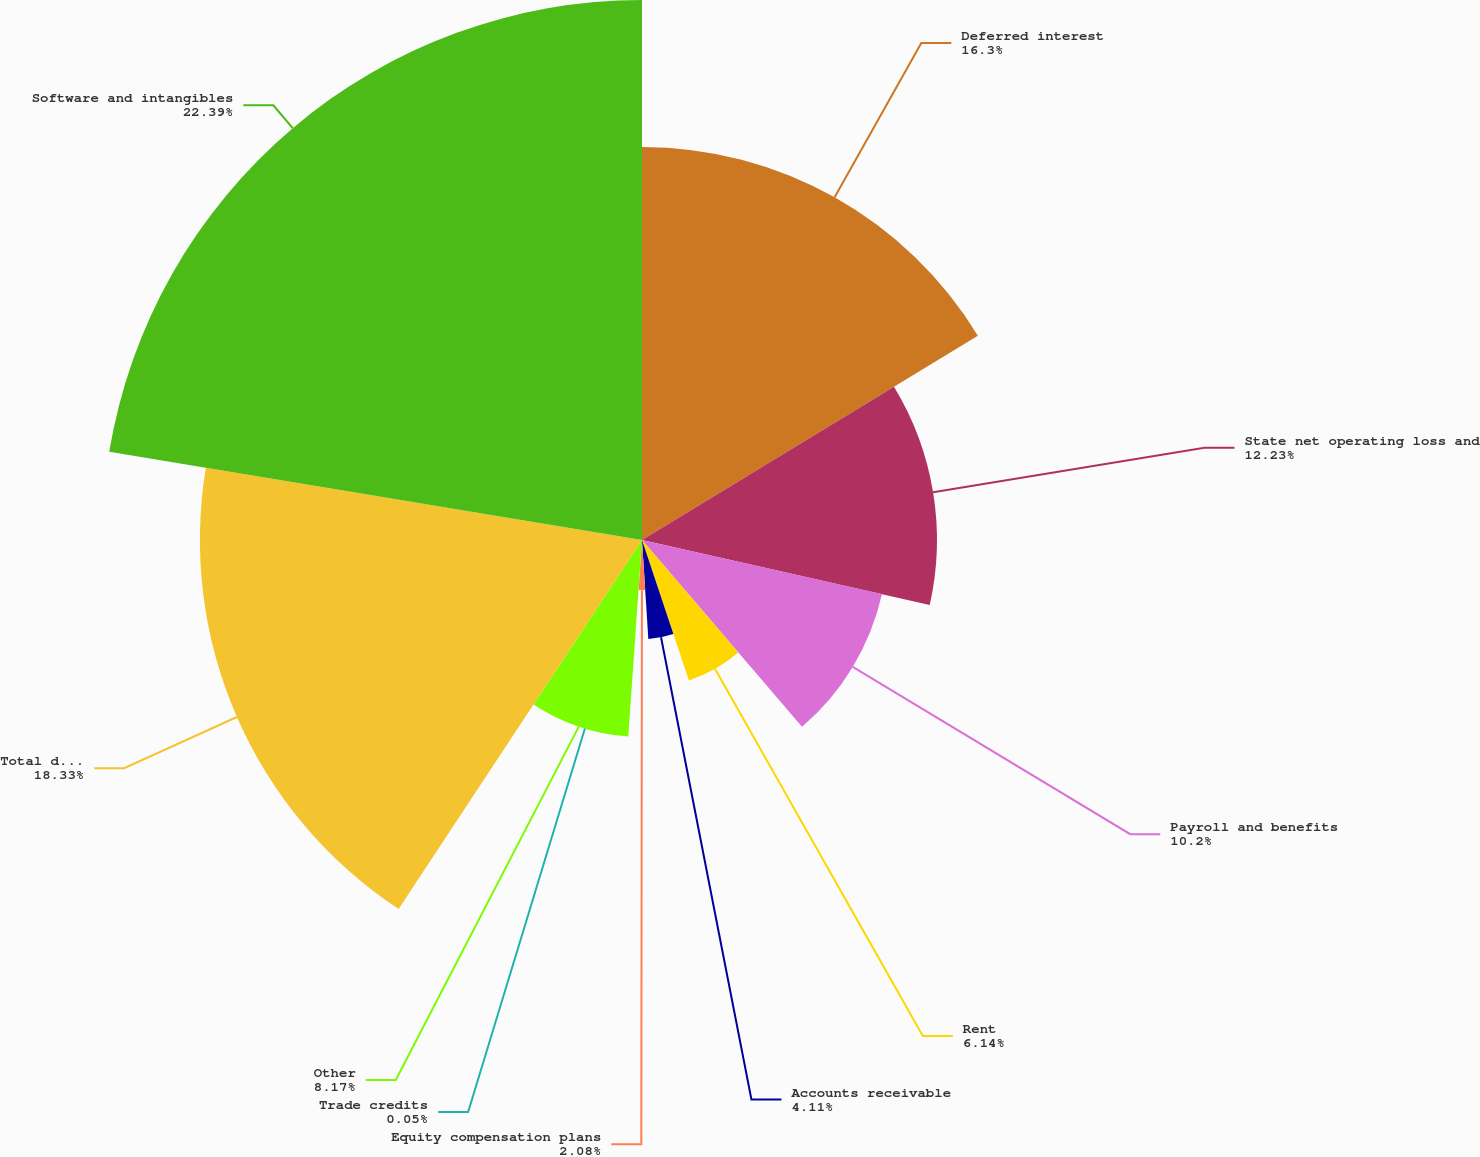<chart> <loc_0><loc_0><loc_500><loc_500><pie_chart><fcel>Deferred interest<fcel>State net operating loss and<fcel>Payroll and benefits<fcel>Rent<fcel>Accounts receivable<fcel>Equity compensation plans<fcel>Trade credits<fcel>Other<fcel>Total deferred tax assets<fcel>Software and intangibles<nl><fcel>16.3%<fcel>12.23%<fcel>10.2%<fcel>6.14%<fcel>4.11%<fcel>2.08%<fcel>0.05%<fcel>8.17%<fcel>18.33%<fcel>22.39%<nl></chart> 